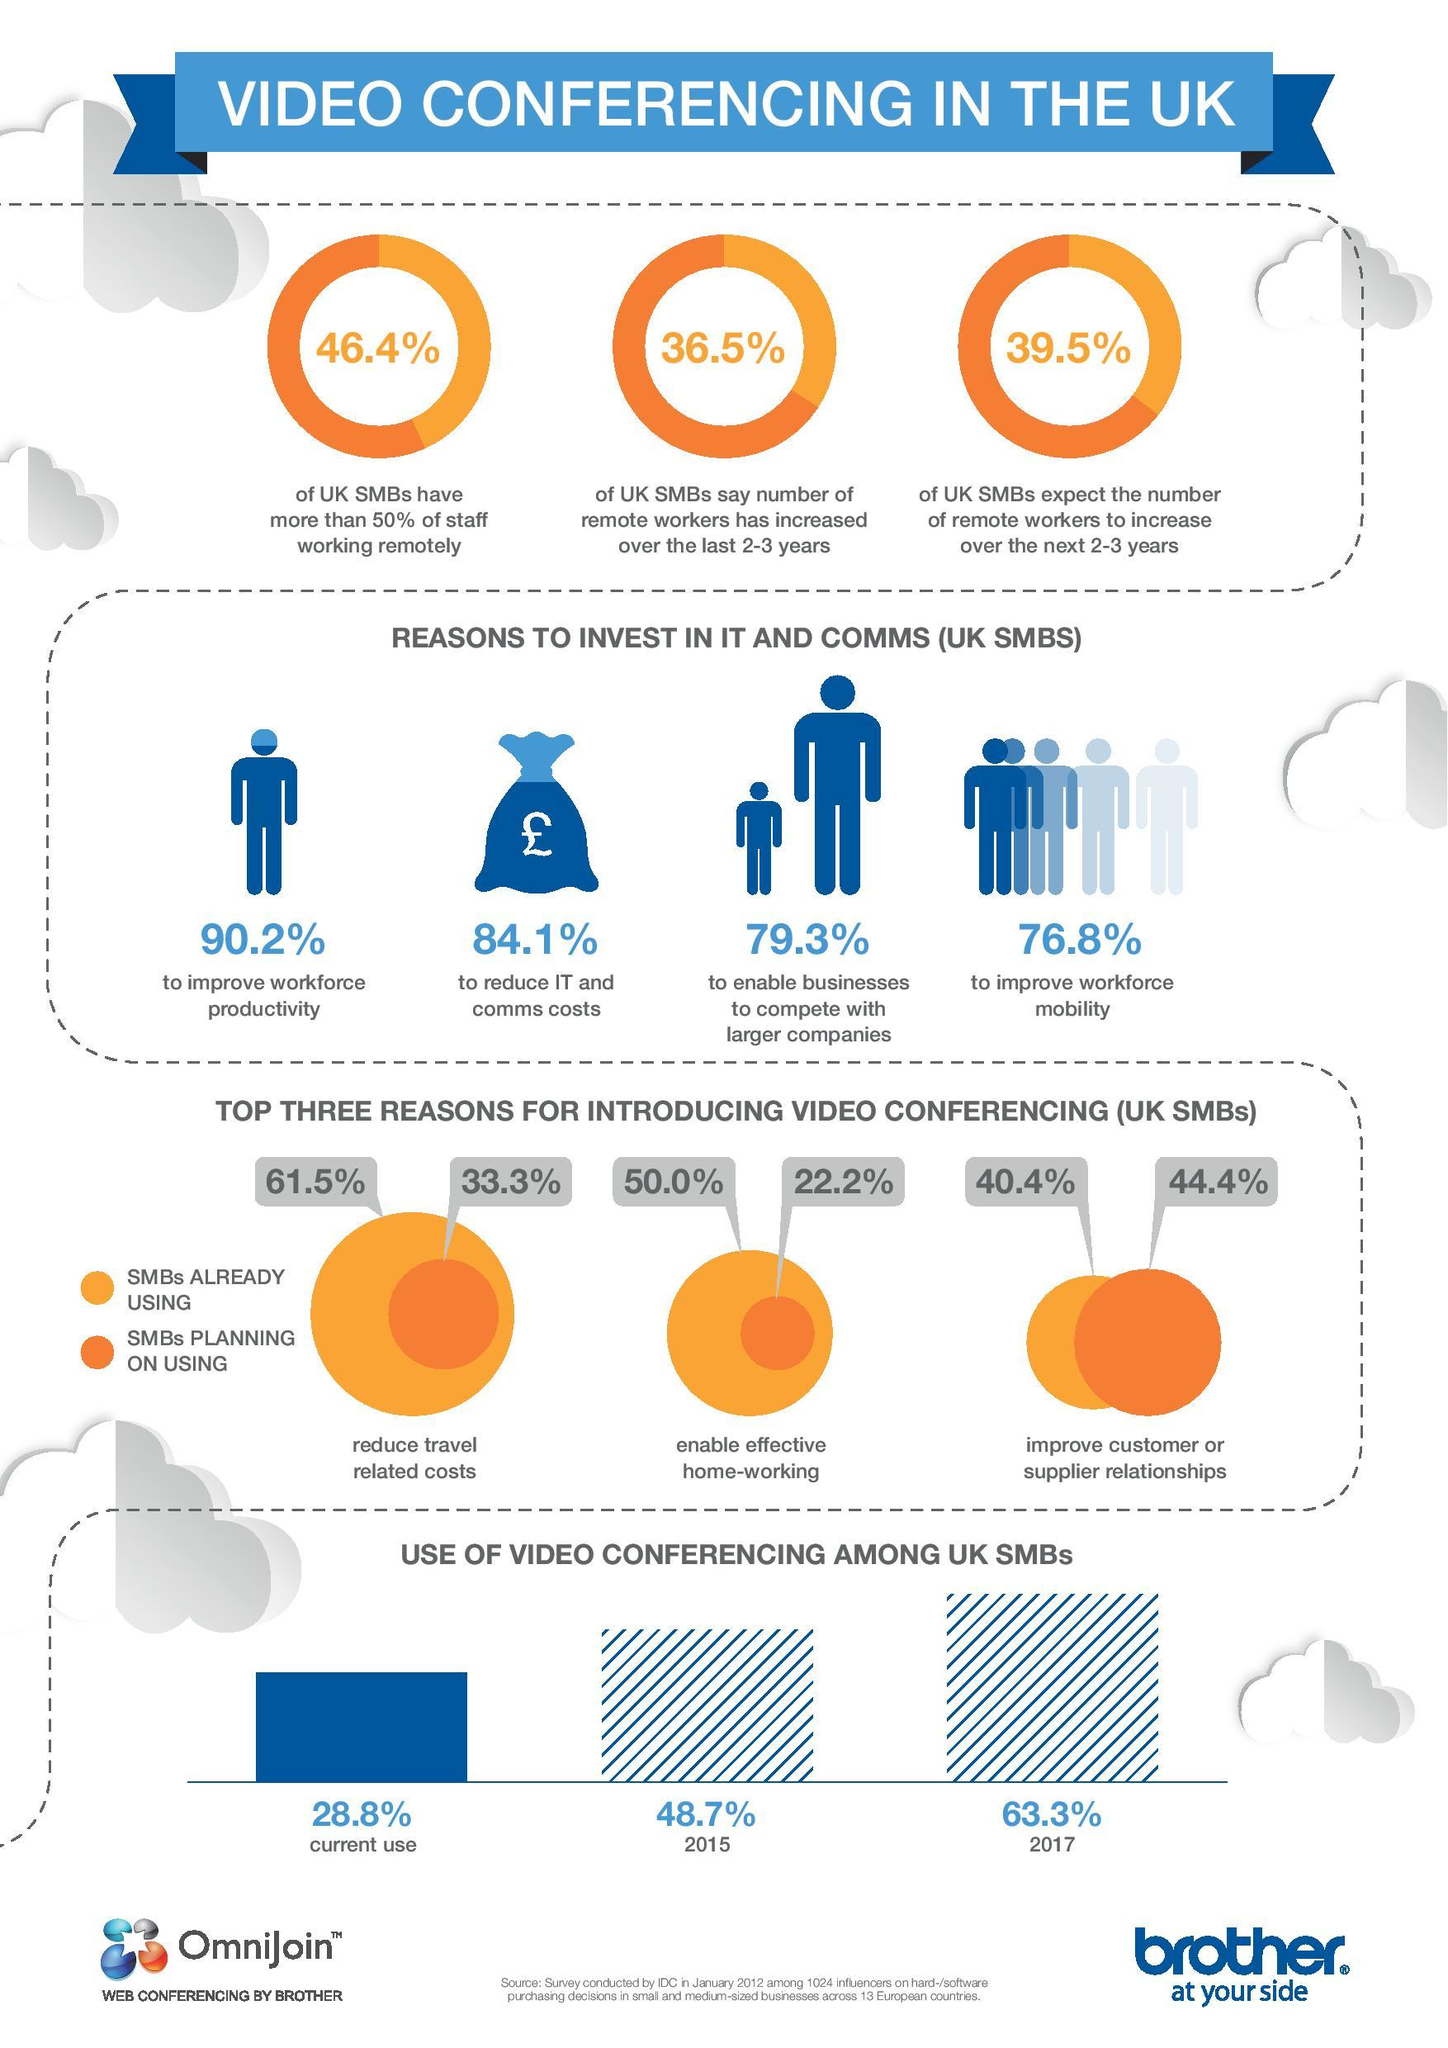Point out several critical features in this image. According to a survey conducted in 2012, 46.4% of UK SMBs had more than half of their staff working remotely. According to a 2012 survey, 22.2% of UK SMBs plan to use video conferencing to enable effective home-working. In 2017, it was estimated that 63.3% of UK SMBs used video conferencing. In a 2012 survey, it was found that 76.8% of UK small and medium-sized businesses were investing in IT and communications to improve workforce mobility. According to a 2012 survey, 33.3% of UK SMBs are planning to use video conferencing to reduce travel-related costs. 